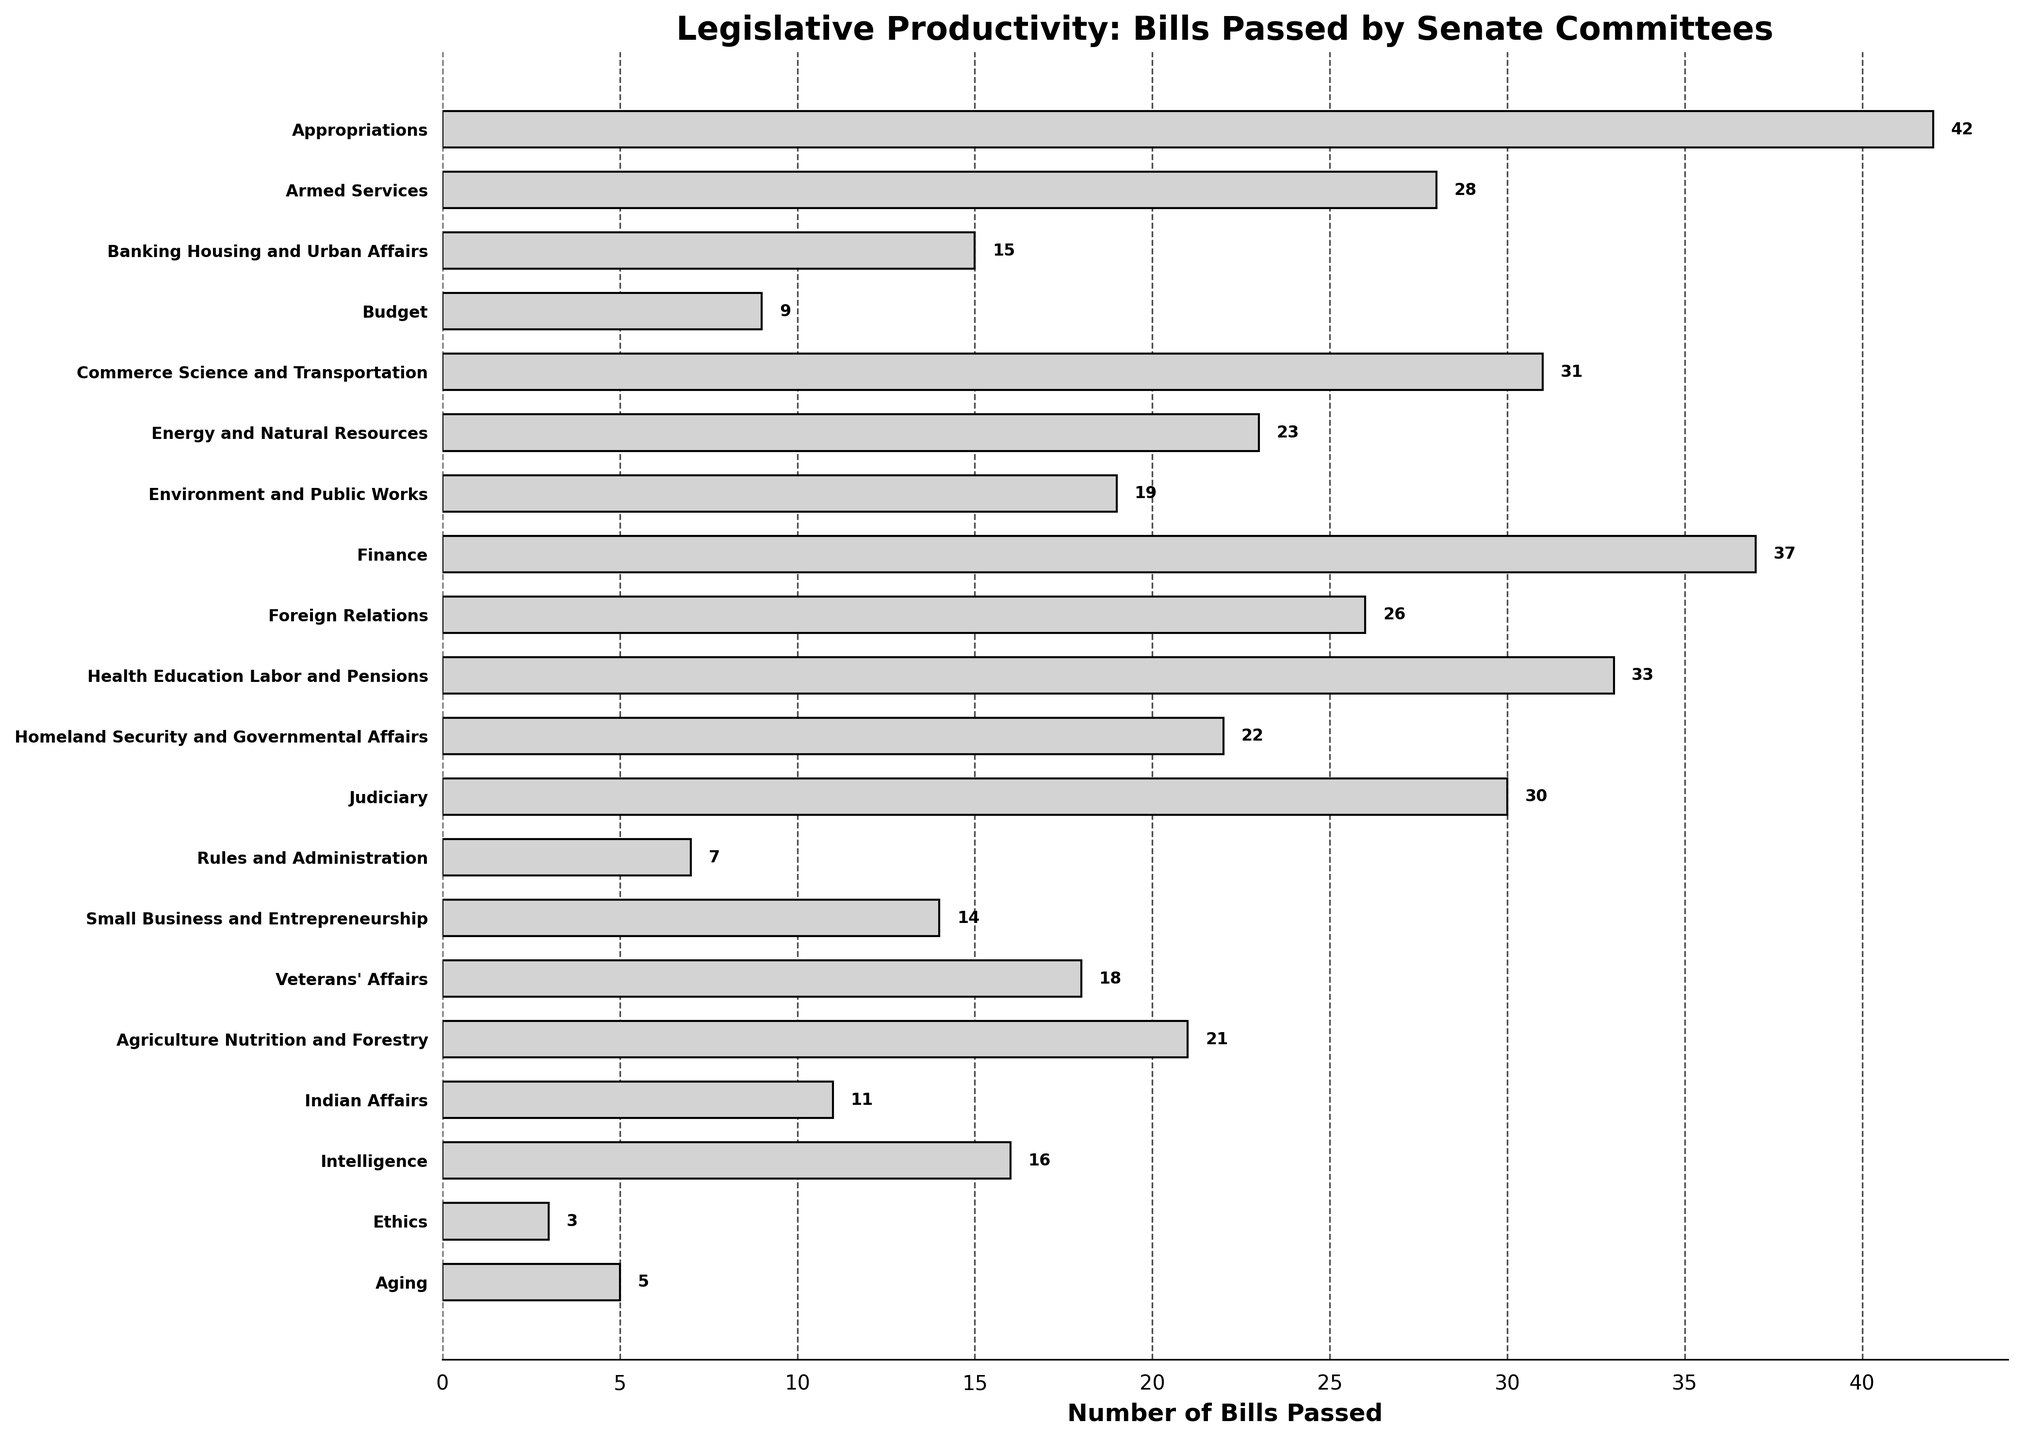Which committee passed the highest number of bills? By looking at the chart, the committee with the longest bar will indicate the highest number of bills passed.
Answer: Appropriations Which committee passed the lowest number of bills? By observing the chart, the committee with the shortest bar indicates the lowest number of bills passed.
Answer: Ethics How many more bills did the Appropriations Committee pass compared to the Budget Committee? Find the difference between the bars representing the Appropriations and Budget Committees. Appropriations passed 42 bills, and Budget passed 9 bills. So, 42 - 9 = 33.
Answer: 33 What is the median number of bills passed by all committees? Sort the number of bills and find the middle value. The sorted numbers are 3, 5, 7, 9, 11, 14, 15, 16, 18, 19, 21, 22, 23, 26, 28, 30, 31, 33, 37, 42. The median is the average of the 10th and 11th numbers: (19 + 21) / 2 = 20.
Answer: 20 Which committee passed exactly 15 bills? Identify the bar with the label “15” next to it and match it to the corresponding committee.
Answer: Banking Housing and Urban Affairs How many committees passed more than 20 bills? Count the bars longer than the 20-bill mark and count them. Committees passing more than 20 bills are Appropriations, Armed Services, Commerce Science and Transportation, Energy and Natural Resources, Finance, Foreign Relations, Health Education Labor and Pensions, and Judiciary.
Answer: 8 What is the total number of bills passed by committees related to security (Armed Services, Homeland Security and Governmental Affairs, Intelligence)? Sum the numbers of bills passed by these specific committees. Armed Services passed 28 bills, Homeland Security and Governmental Affairs passed 22 bills, and Intelligence passed 16 bills. So, 28 + 22 + 16 = 66.
Answer: 66 Among the Health Education Labor and Pensions and Judiciary committees, which passed more bills? Compare the lengths of the bars for these committees. Health Education Labor and Pensions passed 33 bills, and Judiciary passed 30 bills, thus Health Education Labor and Pensions passed more.
Answer: Health Education Labor and Pensions Calculate the difference between the number of bills passed by the highest and lowest performing committees. Subtract the number of bills passed by Ethics (lowest, 3) from those passed by Appropriations (highest, 42). So, 42 - 3 = 39.
Answer: 39 